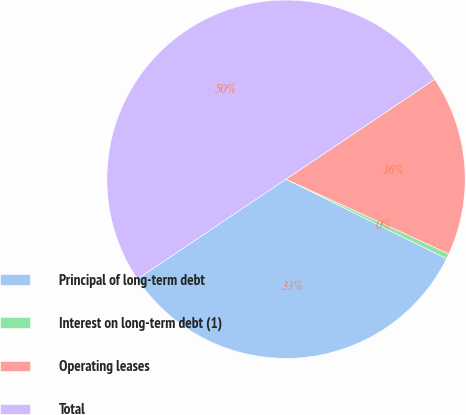Convert chart. <chart><loc_0><loc_0><loc_500><loc_500><pie_chart><fcel>Principal of long-term debt<fcel>Interest on long-term debt (1)<fcel>Operating leases<fcel>Total<nl><fcel>33.27%<fcel>0.47%<fcel>16.26%<fcel>50.0%<nl></chart> 